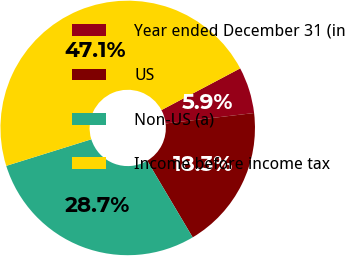Convert chart. <chart><loc_0><loc_0><loc_500><loc_500><pie_chart><fcel>Year ended December 31 (in<fcel>US<fcel>Non-US (a)<fcel>Income before income tax<nl><fcel>5.88%<fcel>18.34%<fcel>28.71%<fcel>47.06%<nl></chart> 